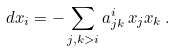Convert formula to latex. <formula><loc_0><loc_0><loc_500><loc_500>d x _ { i } = - \sum _ { j , k > i } a _ { j k } ^ { i } \, x _ { j } x _ { k } \, .</formula> 